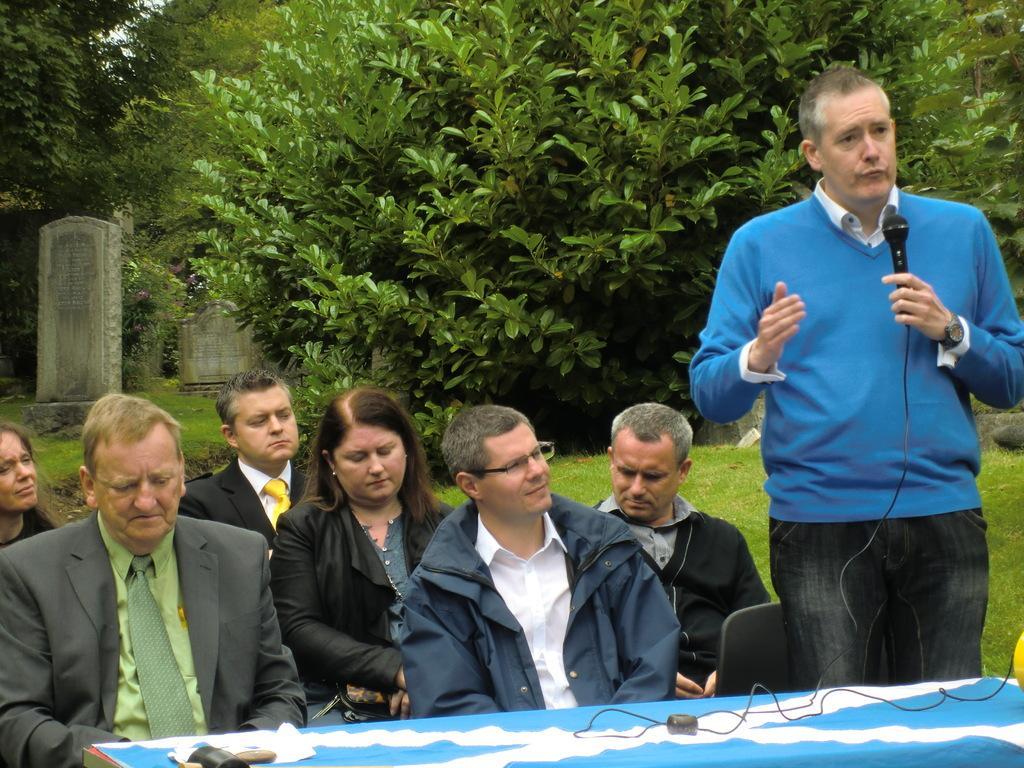How would you summarize this image in a sentence or two? As we can see in the image, in the front there is a table. It is covered with blue color cloth and there are group of people. These people are listening to the person standing on the right. This person is wearing a blue color shirt and he is talking and in the background there are a group of trees. 